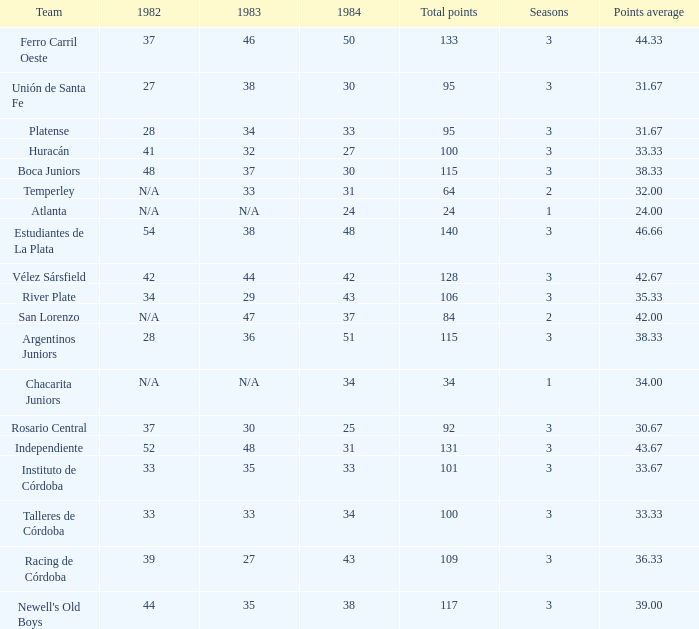What is the number of seasons for the team with a total fewer than 24? None. 